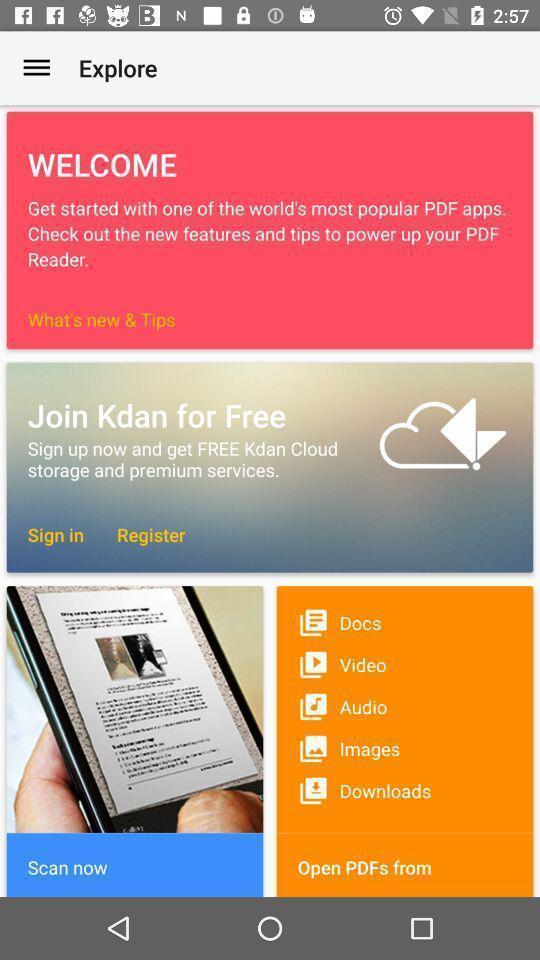Provide a detailed account of this screenshot. Page displaying various options in a pdf reader app. 